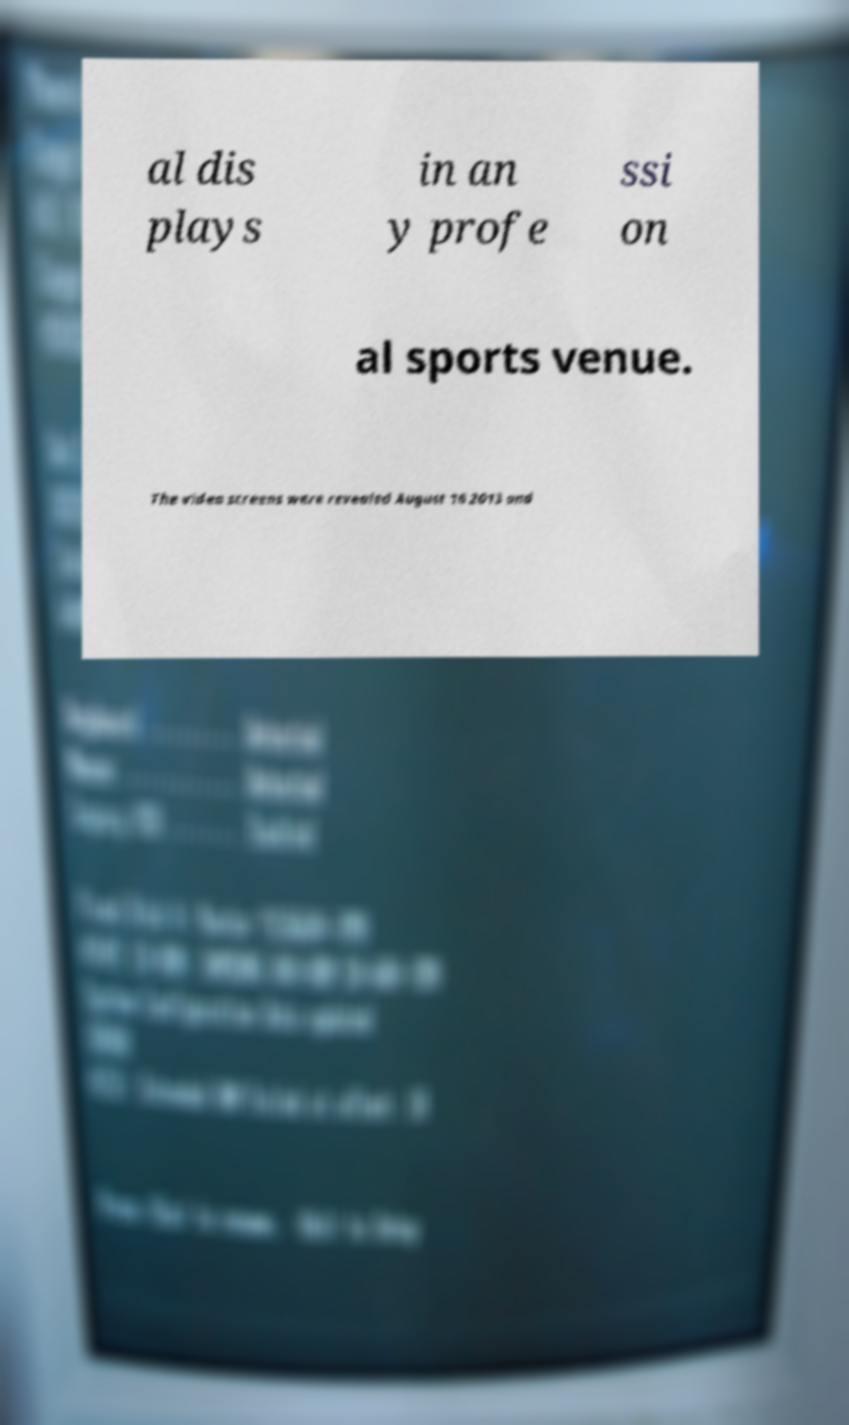Please read and relay the text visible in this image. What does it say? al dis plays in an y profe ssi on al sports venue. The video screens were revealed August 16 2013 and 